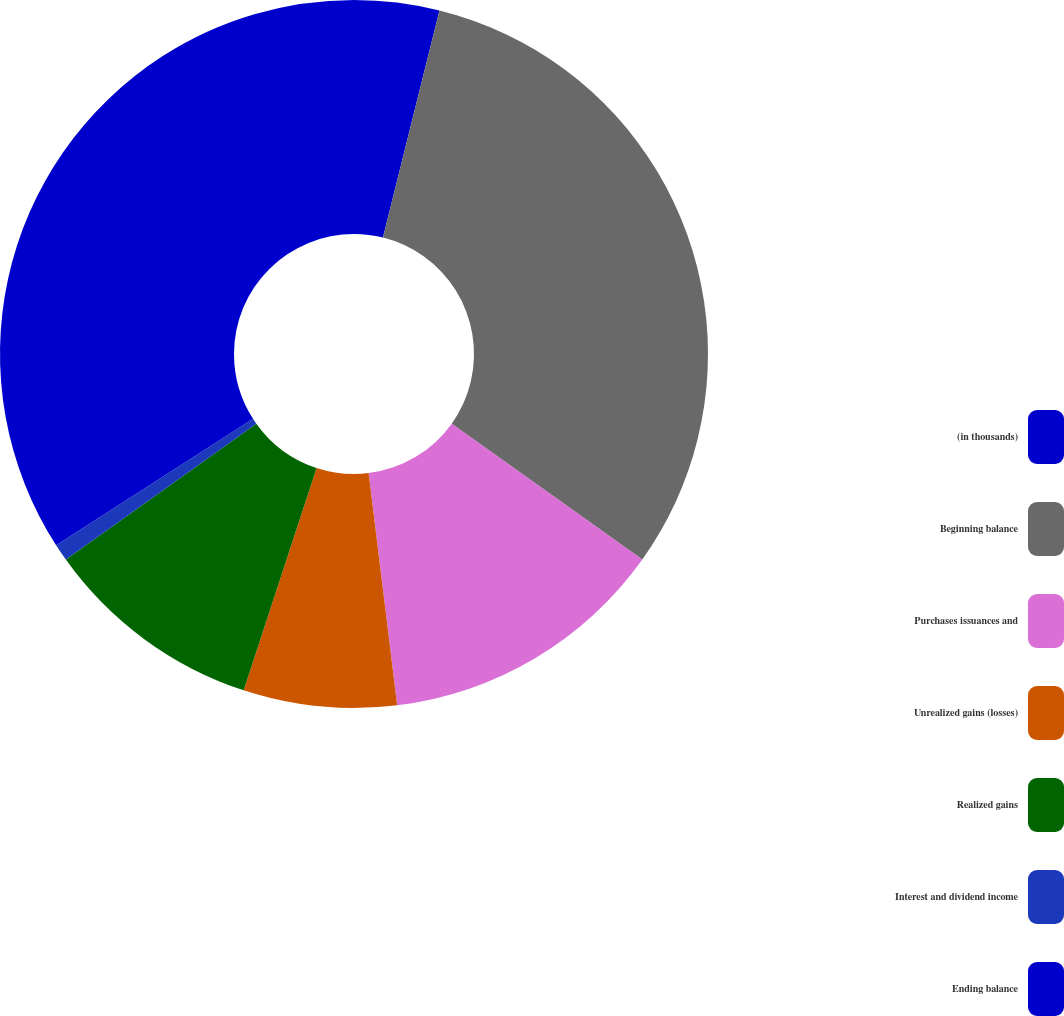<chart> <loc_0><loc_0><loc_500><loc_500><pie_chart><fcel>(in thousands)<fcel>Beginning balance<fcel>Purchases issuances and<fcel>Unrealized gains (losses)<fcel>Realized gains<fcel>Interest and dividend income<fcel>Ending balance<nl><fcel>3.88%<fcel>30.97%<fcel>13.2%<fcel>6.99%<fcel>10.09%<fcel>0.78%<fcel>34.08%<nl></chart> 